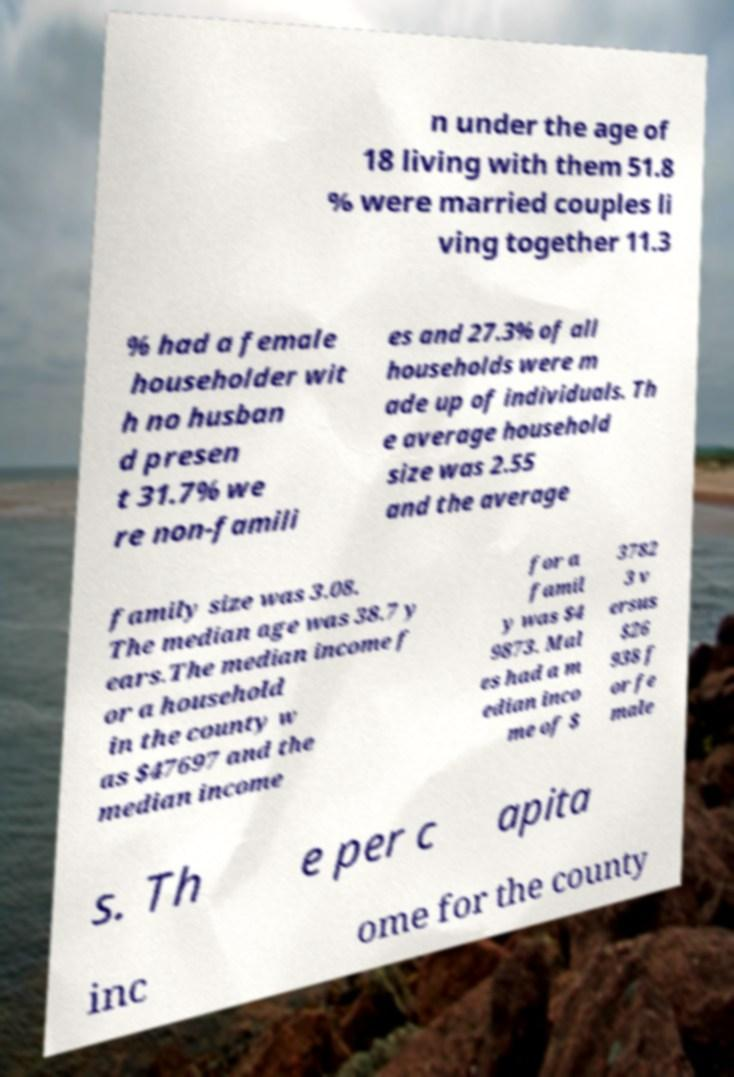Please identify and transcribe the text found in this image. n under the age of 18 living with them 51.8 % were married couples li ving together 11.3 % had a female householder wit h no husban d presen t 31.7% we re non-famili es and 27.3% of all households were m ade up of individuals. Th e average household size was 2.55 and the average family size was 3.08. The median age was 38.7 y ears.The median income f or a household in the county w as $47697 and the median income for a famil y was $4 9873. Mal es had a m edian inco me of $ 3782 3 v ersus $26 938 f or fe male s. Th e per c apita inc ome for the county 